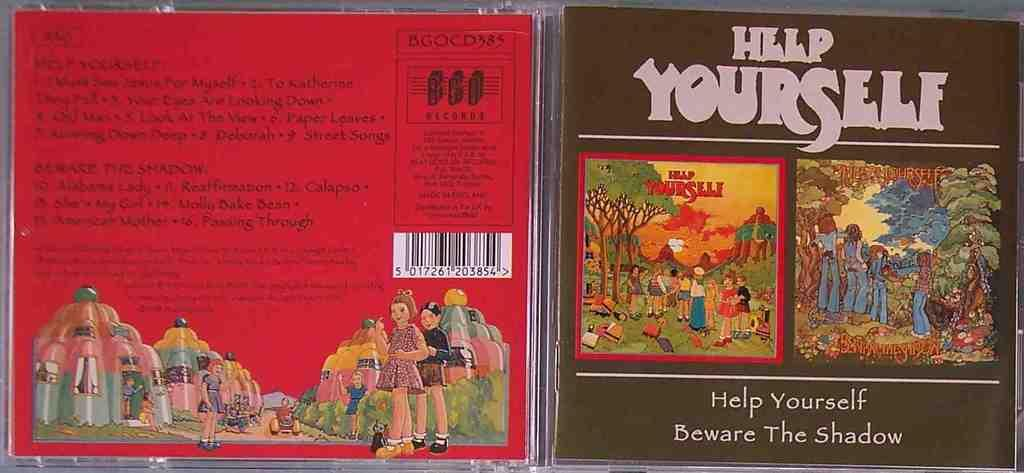<image>
Provide a brief description of the given image. A CD cover is opened showing both sides for the Help Yourself CD. 